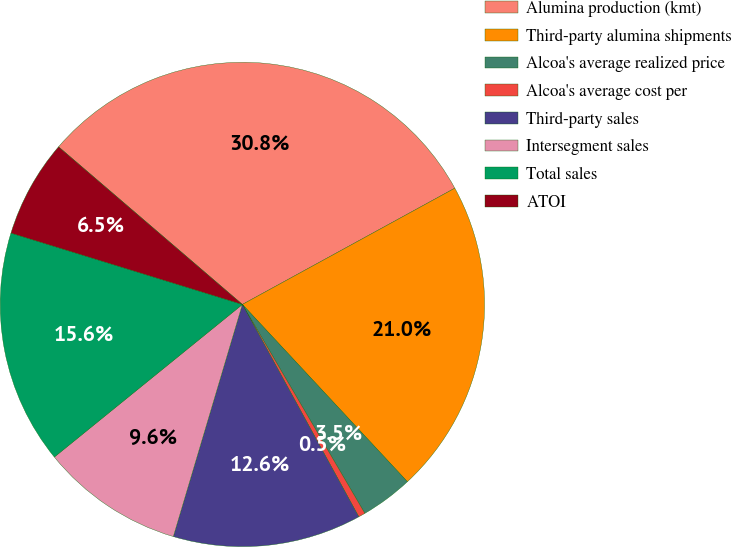Convert chart to OTSL. <chart><loc_0><loc_0><loc_500><loc_500><pie_chart><fcel>Alumina production (kmt)<fcel>Third-party alumina shipments<fcel>Alcoa's average realized price<fcel>Alcoa's average cost per<fcel>Third-party sales<fcel>Intersegment sales<fcel>Total sales<fcel>ATOI<nl><fcel>30.75%<fcel>21.04%<fcel>3.49%<fcel>0.46%<fcel>12.58%<fcel>9.55%<fcel>15.61%<fcel>6.52%<nl></chart> 